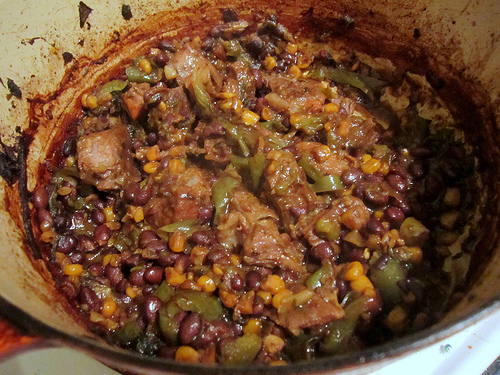<image>
Is the corn above the bean? No. The corn is not positioned above the bean. The vertical arrangement shows a different relationship. 